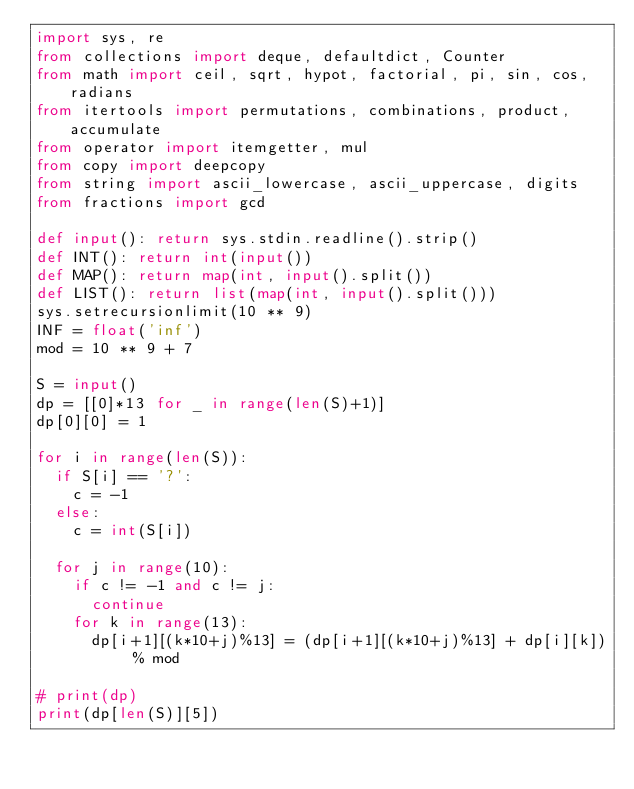<code> <loc_0><loc_0><loc_500><loc_500><_Python_>import sys, re
from collections import deque, defaultdict, Counter
from math import ceil, sqrt, hypot, factorial, pi, sin, cos, radians
from itertools import permutations, combinations, product, accumulate
from operator import itemgetter, mul
from copy import deepcopy
from string import ascii_lowercase, ascii_uppercase, digits
from fractions import gcd

def input(): return sys.stdin.readline().strip()
def INT(): return int(input())
def MAP(): return map(int, input().split())
def LIST(): return list(map(int, input().split()))
sys.setrecursionlimit(10 ** 9)
INF = float('inf')
mod = 10 ** 9 + 7

S = input()
dp = [[0]*13 for _ in range(len(S)+1)]
dp[0][0] = 1

for i in range(len(S)):
	if S[i] == '?':
		c = -1
	else:
		c = int(S[i])

	for j in range(10):
		if c != -1 and c != j:
			continue
		for k in range(13):
			dp[i+1][(k*10+j)%13] = (dp[i+1][(k*10+j)%13] + dp[i][k]) % mod

# print(dp)
print(dp[len(S)][5])
</code> 